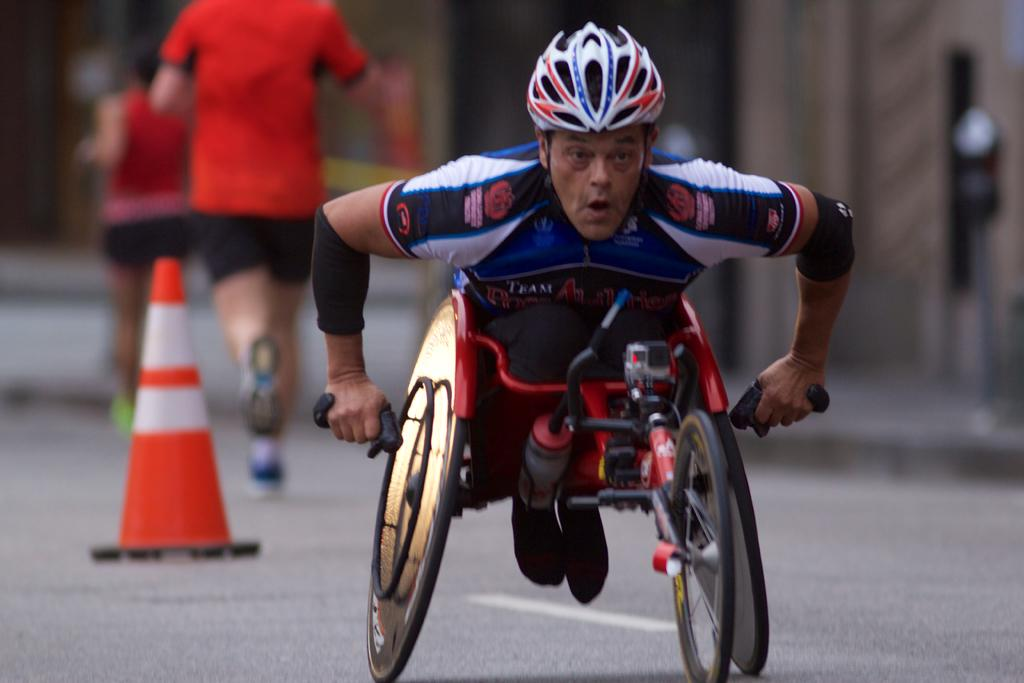What is the person in the image doing? The person is sitting in a tricycle in the image. What can be seen in the background of the image? There are persons standing on the road and a traffic cone visible in the background of the image. What else is visible in the background of the image? There are buildings in the background of the image. What type of salt can be seen on the person's hands in the image? There is no salt visible on the person's hands in the image. How many brothers are present in the image? The image does not depict any brothers; it only shows a person sitting in a tricycle and other elements in the background. 